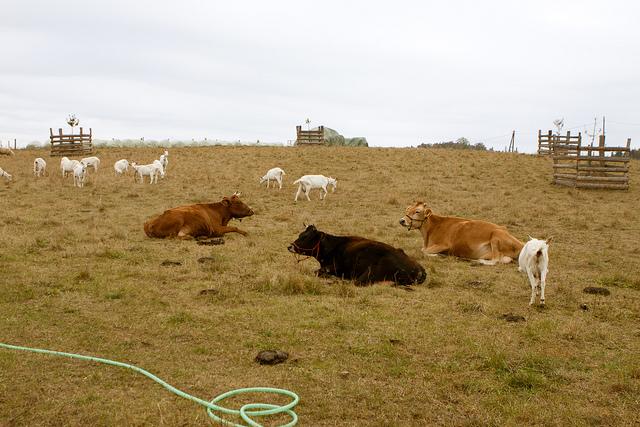How many cows are lying down?
Quick response, please. 3. Do you see a hose?
Write a very short answer. Yes. How many black cows are there?
Quick response, please. 1. What are the white animals?
Write a very short answer. Goats. How many brown cows are there?
Answer briefly. 3. Are any of the cows spotted?
Be succinct. No. Are they related?
Concise answer only. No. 